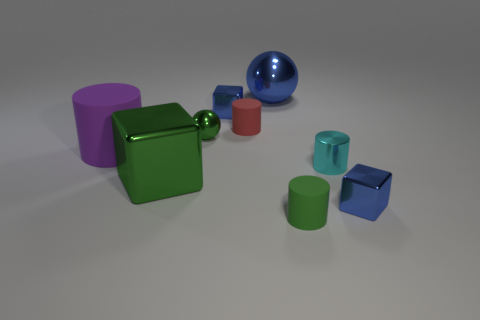Subtract 1 cylinders. How many cylinders are left? 3 Add 1 tiny metallic balls. How many objects exist? 10 Subtract all balls. How many objects are left? 7 Subtract all small green metallic things. Subtract all purple rubber objects. How many objects are left? 7 Add 3 red rubber cylinders. How many red rubber cylinders are left? 4 Add 9 green metal cubes. How many green metal cubes exist? 10 Subtract 0 red blocks. How many objects are left? 9 